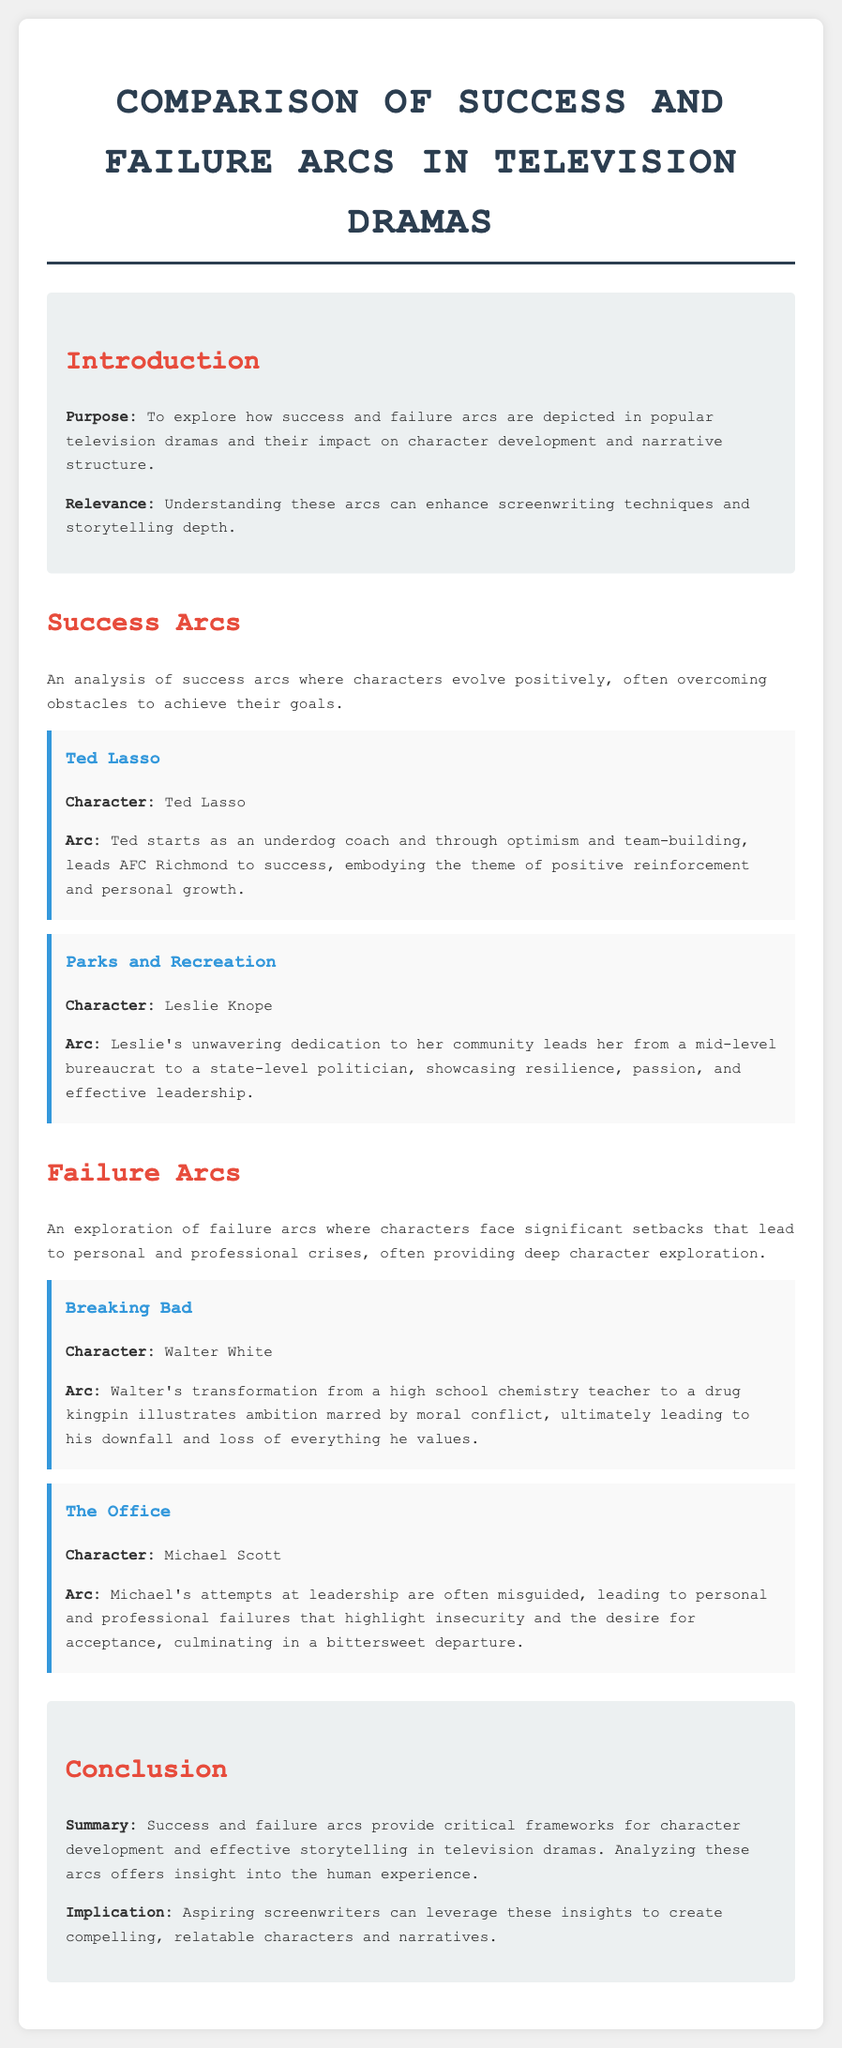What is the purpose of the document? The purpose is to explore how success and failure arcs are depicted in popular television dramas and their impact on character development and narrative structure.
Answer: To explore how success and failure arcs are depicted in popular television dramas and their impact on character development and narrative structure Who is the main character in "Ted Lasso"? The main character in "Ted Lasso" is Ted Lasso.
Answer: Ted Lasso What arc does Leslie Knope experience? Leslie Knope evolves from a mid-level bureaucrat to a state-level politician, showcasing resilience and effective leadership.
Answer: From a mid-level bureaucrat to a state-level politician In which show does Walter White appear? Walter White appears in "Breaking Bad."
Answer: Breaking Bad What major theme is illustrated by Ted Lasso's character arc? The major theme illustrated is positive reinforcement and personal growth.
Answer: Positive reinforcement and personal growth How does Michael Scott's arc reflect his personality? Michael Scott's arc highlights insecurity and the desire for acceptance.
Answer: Insecurity and the desire for acceptance What do success and failure arcs provide in television dramas? They provide critical frameworks for character development and effective storytelling.
Answer: Critical frameworks for character development and effective storytelling How many example characters are listed under success arcs? There are two example characters listed under success arcs.
Answer: Two What is the implication for aspiring screenwriters mentioned in the conclusion? Aspiring screenwriters can leverage these insights to create compelling, relatable characters and narratives.
Answer: To create compelling, relatable characters and narratives 